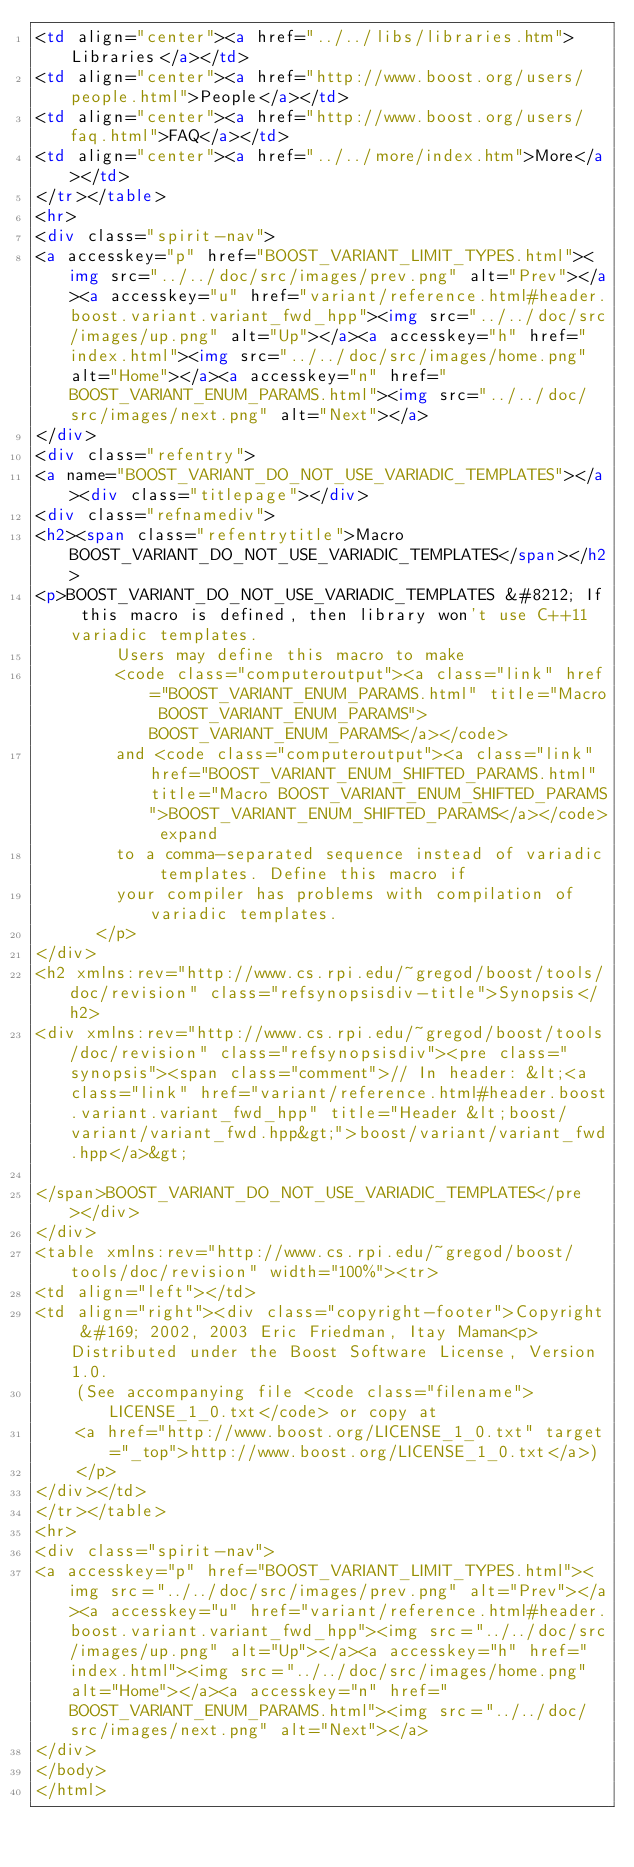<code> <loc_0><loc_0><loc_500><loc_500><_HTML_><td align="center"><a href="../../libs/libraries.htm">Libraries</a></td>
<td align="center"><a href="http://www.boost.org/users/people.html">People</a></td>
<td align="center"><a href="http://www.boost.org/users/faq.html">FAQ</a></td>
<td align="center"><a href="../../more/index.htm">More</a></td>
</tr></table>
<hr>
<div class="spirit-nav">
<a accesskey="p" href="BOOST_VARIANT_LIMIT_TYPES.html"><img src="../../doc/src/images/prev.png" alt="Prev"></a><a accesskey="u" href="variant/reference.html#header.boost.variant.variant_fwd_hpp"><img src="../../doc/src/images/up.png" alt="Up"></a><a accesskey="h" href="index.html"><img src="../../doc/src/images/home.png" alt="Home"></a><a accesskey="n" href="BOOST_VARIANT_ENUM_PARAMS.html"><img src="../../doc/src/images/next.png" alt="Next"></a>
</div>
<div class="refentry">
<a name="BOOST_VARIANT_DO_NOT_USE_VARIADIC_TEMPLATES"></a><div class="titlepage"></div>
<div class="refnamediv">
<h2><span class="refentrytitle">Macro BOOST_VARIANT_DO_NOT_USE_VARIADIC_TEMPLATES</span></h2>
<p>BOOST_VARIANT_DO_NOT_USE_VARIADIC_TEMPLATES &#8212; If this macro is defined, then library won't use C++11 variadic templates.
        Users may define this macro to make 
        <code class="computeroutput"><a class="link" href="BOOST_VARIANT_ENUM_PARAMS.html" title="Macro BOOST_VARIANT_ENUM_PARAMS">BOOST_VARIANT_ENUM_PARAMS</a></code>
        and <code class="computeroutput"><a class="link" href="BOOST_VARIANT_ENUM_SHIFTED_PARAMS.html" title="Macro BOOST_VARIANT_ENUM_SHIFTED_PARAMS">BOOST_VARIANT_ENUM_SHIFTED_PARAMS</a></code> expand
        to a comma-separated sequence instead of variadic templates. Define this macro if
        your compiler has problems with compilation of variadic templates.
      </p>
</div>
<h2 xmlns:rev="http://www.cs.rpi.edu/~gregod/boost/tools/doc/revision" class="refsynopsisdiv-title">Synopsis</h2>
<div xmlns:rev="http://www.cs.rpi.edu/~gregod/boost/tools/doc/revision" class="refsynopsisdiv"><pre class="synopsis"><span class="comment">// In header: &lt;<a class="link" href="variant/reference.html#header.boost.variant.variant_fwd_hpp" title="Header &lt;boost/variant/variant_fwd.hpp&gt;">boost/variant/variant_fwd.hpp</a>&gt;

</span>BOOST_VARIANT_DO_NOT_USE_VARIADIC_TEMPLATES</pre></div>
</div>
<table xmlns:rev="http://www.cs.rpi.edu/~gregod/boost/tools/doc/revision" width="100%"><tr>
<td align="left"></td>
<td align="right"><div class="copyright-footer">Copyright &#169; 2002, 2003 Eric Friedman, Itay Maman<p>Distributed under the Boost Software License, Version 1.0.
    (See accompanying file <code class="filename">LICENSE_1_0.txt</code> or copy at 
    <a href="http://www.boost.org/LICENSE_1_0.txt" target="_top">http://www.boost.org/LICENSE_1_0.txt</a>)
    </p>
</div></td>
</tr></table>
<hr>
<div class="spirit-nav">
<a accesskey="p" href="BOOST_VARIANT_LIMIT_TYPES.html"><img src="../../doc/src/images/prev.png" alt="Prev"></a><a accesskey="u" href="variant/reference.html#header.boost.variant.variant_fwd_hpp"><img src="../../doc/src/images/up.png" alt="Up"></a><a accesskey="h" href="index.html"><img src="../../doc/src/images/home.png" alt="Home"></a><a accesskey="n" href="BOOST_VARIANT_ENUM_PARAMS.html"><img src="../../doc/src/images/next.png" alt="Next"></a>
</div>
</body>
</html>
</code> 